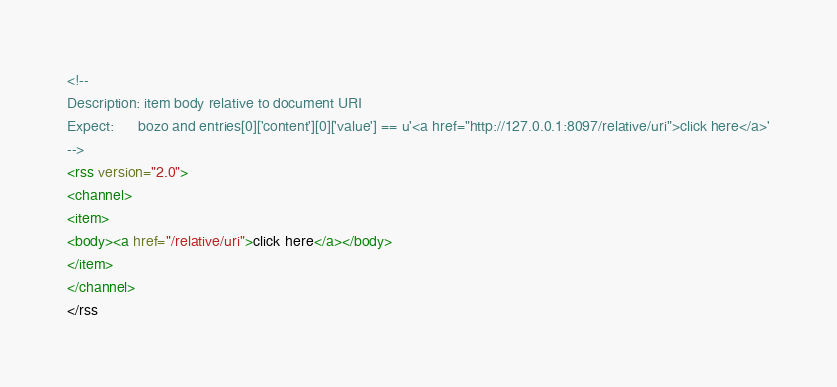<code> <loc_0><loc_0><loc_500><loc_500><_XML_><!--
Description: item body relative to document URI
Expect:      bozo and entries[0]['content'][0]['value'] == u'<a href="http://127.0.0.1:8097/relative/uri">click here</a>'
-->
<rss version="2.0">
<channel>
<item>
<body><a href="/relative/uri">click here</a></body>
</item>
</channel>
</rss</code> 